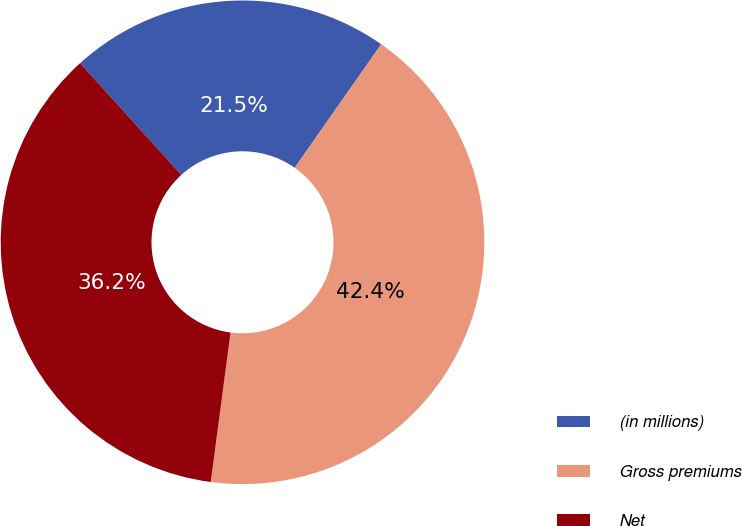Convert chart to OTSL. <chart><loc_0><loc_0><loc_500><loc_500><pie_chart><fcel>(in millions)<fcel>Gross premiums<fcel>Net<nl><fcel>21.45%<fcel>42.37%<fcel>36.18%<nl></chart> 